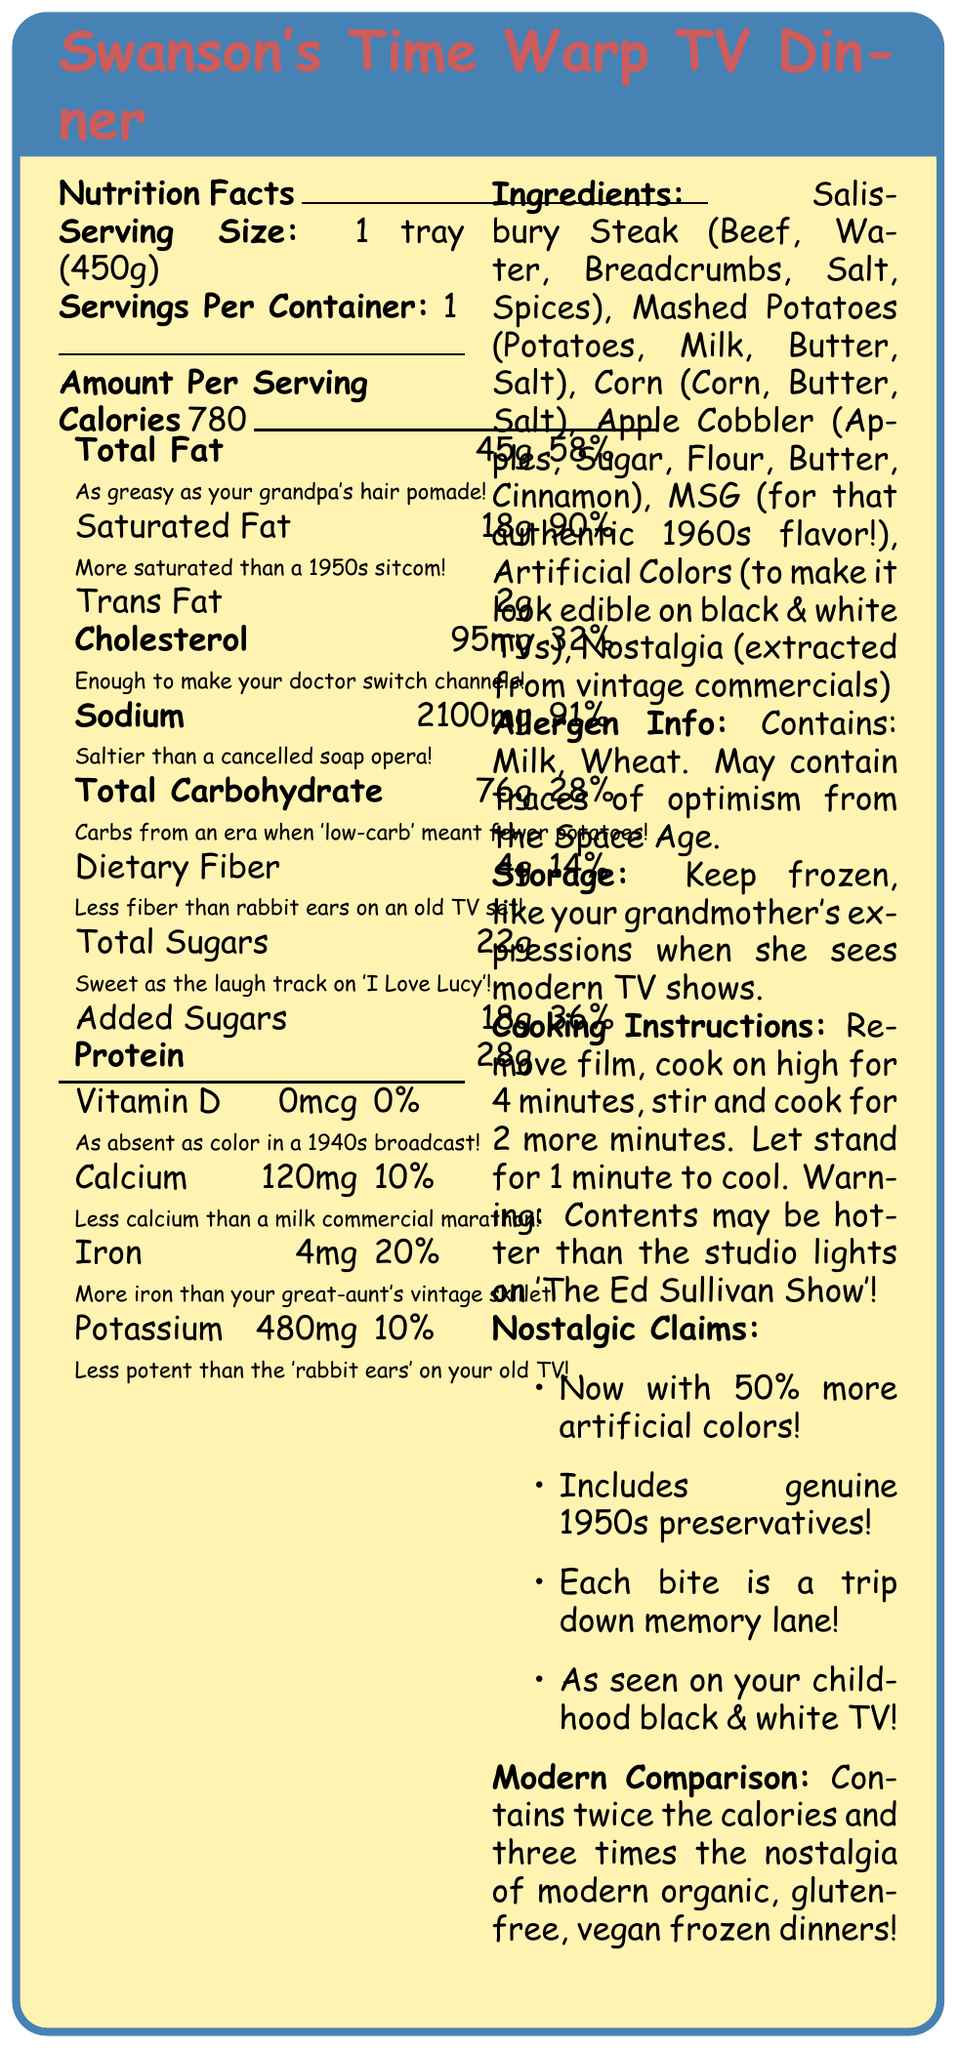what is the serving size for Swanson's Time Warp TV Dinner? The serving size is clearly stated as "1 tray (450g)" in the document.
Answer: 1 tray (450g) how many calories are there per serving? The document states that there are 780 calories per serving.
Answer: 780 what is the percentage of the daily value of total fat in this TV dinner? The document indicates that the total fat is 45g, which is 58% of the daily value.
Answer: 58% which ingredient is included for its authentic 1960s flavor? The document lists MSG as an ingredient, specifically mentioning it is included "for that authentic 1960s flavor!"
Answer: MSG what is the sodium content in this TV dinner? The document shows the sodium content as 2100mg, equating to 91% of the daily value.
Answer: 2100mg what subtitle describes the saturated fat content? The subtitle for saturated fat is "More saturated than a 1950s sitcom!"
Answer: More saturated than a 1950s sitcom! For those watching their sugar intake, what is the amount of added sugars? The document states that there are 18g of added sugars.
Answer: 18g which of the following vitamins or minerals is completely absent in the TV dinner? A. Vitamin D B. Calcium C. Iron D. Potassium The document indicates that Vitamin D is 0mcg, which is 0% of the daily value, making it completely absent.
Answer: A. Vitamin D which comparison is given for the taste of the total sugars? A. Fun as the 'Brady Bunch' B. Sweet as the laugh track on 'I Love Lucy' C. Exciting as 'Star Trek' D. Thrilling as 'Twilight Zone' The document states "Sweet as the laugh track on 'I Love Lucy'" to compare the taste of the total sugars.
Answer: B. Sweet as the laugh track on 'I Love Lucy' are there any artificial colors used in this TV dinner? The document lists "Artificial Colors (to make it look edible on black & white TVs)" as an ingredient.
Answer: Yes summarize the main information given in this document. The document provides detailed nutrition facts, ingredient lists, and cooking instructions for Swanson's Time Warp TV Dinner, infusing humor and nostalgic comparisons to classic television shows while highlighting high levels of certain nutrients and preservatives.
Answer: Swanson's Time Warp TV Dinner is a nostalgic TV dinner with a serving size of 1 tray (450g) and 780 calories per serving. It contains high amounts of total fat, saturated fat, sodium, and total sugars. The product includes ingredients like Salisbury steak, mashed potatoes, corn, apple cobbler, MSG, and artificial colors. The document humorously compares nutrition facts to vintage TV shows and provides cooking instructions, allergen info, and nostalgic claims. what era's commercials are the sense of nostalgia extracted from? The document mentions nostalgia extracted from vintage commercials but does not specify the exact era or commercials.
Answer: Cannot be determined 